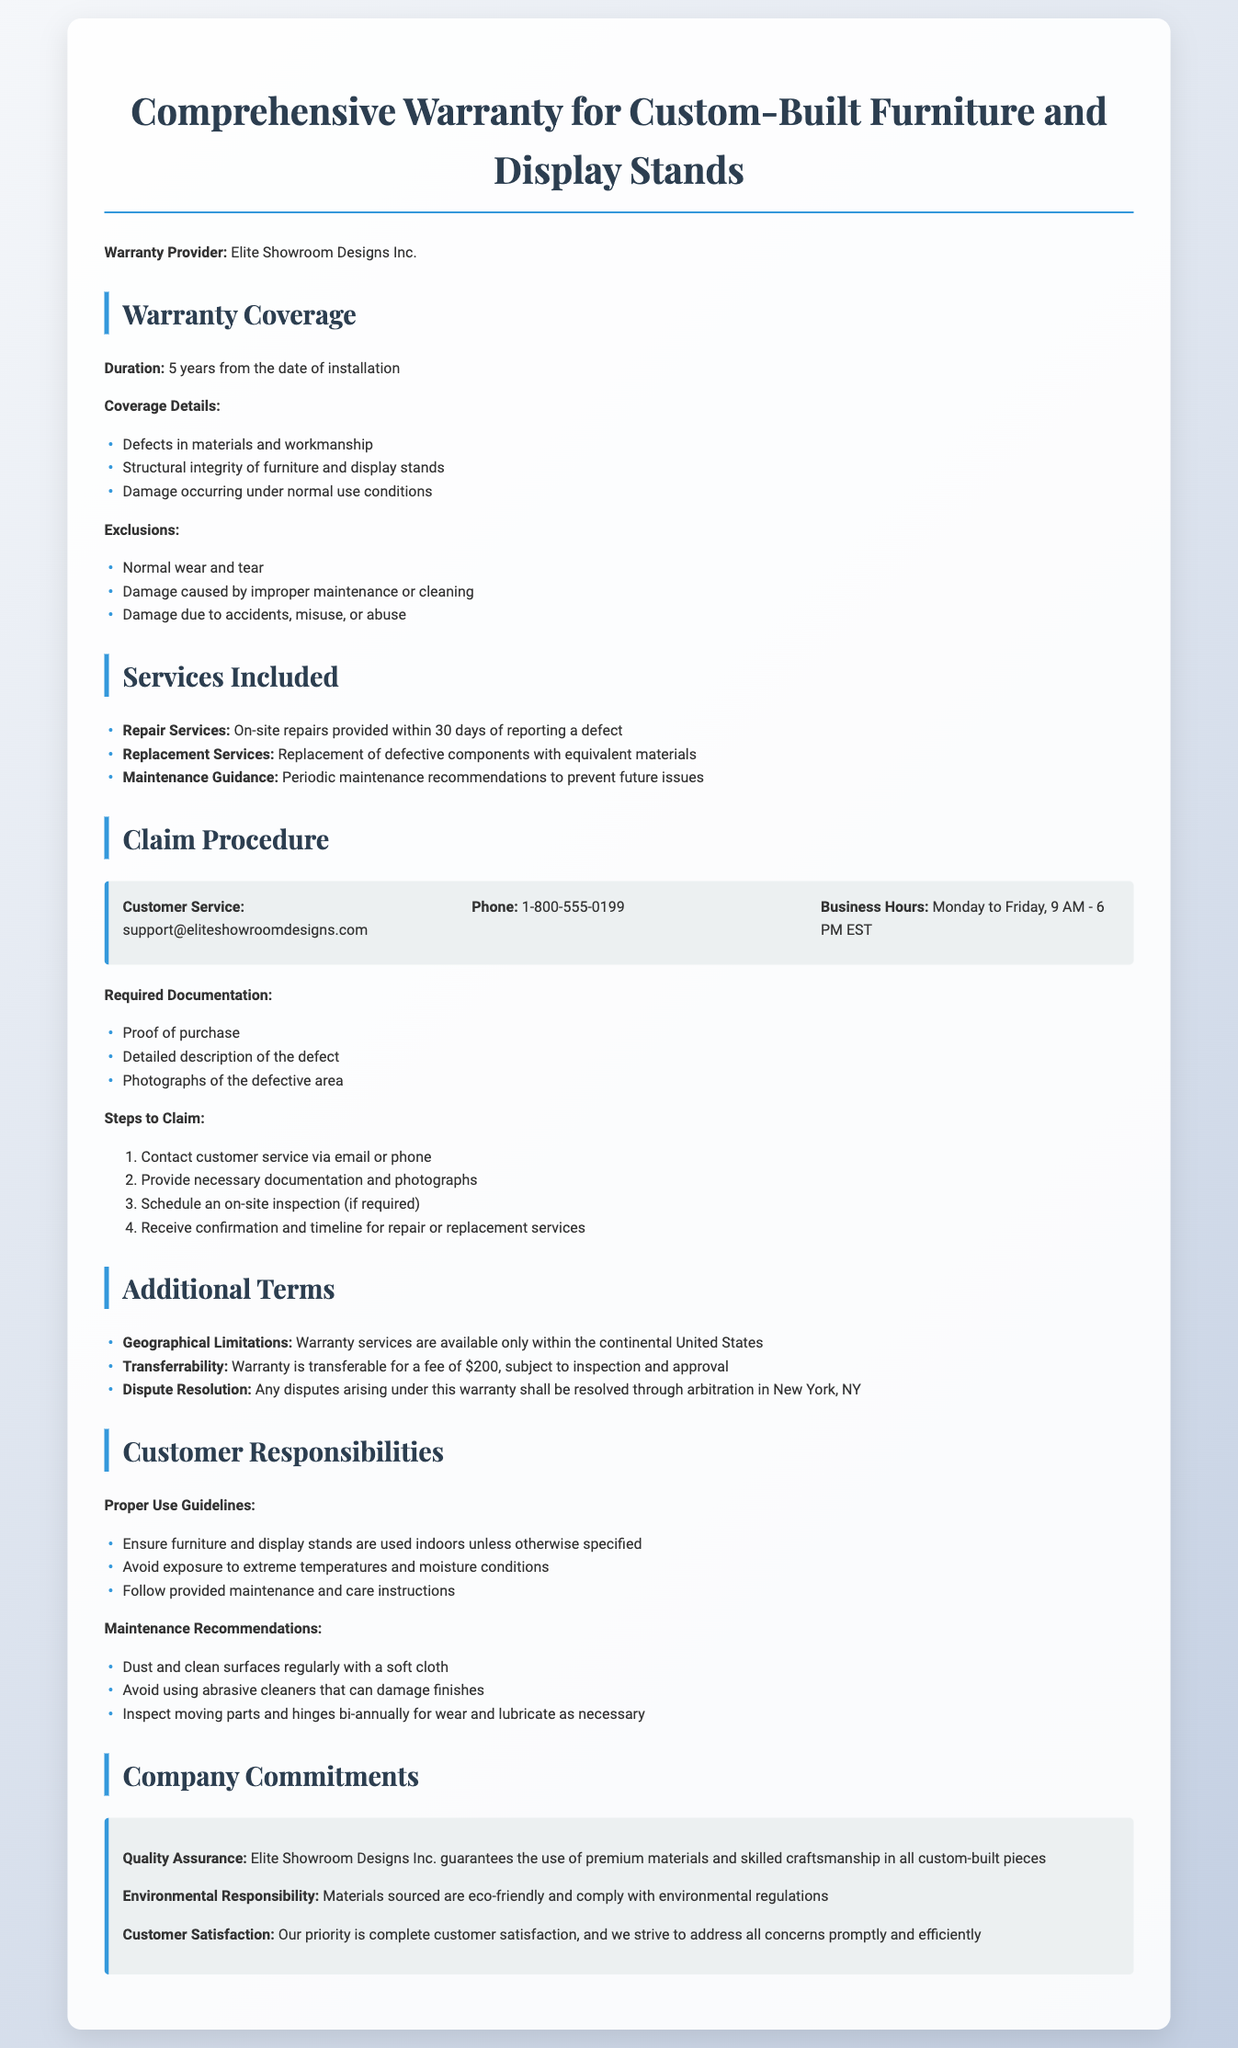What is the warranty duration? The warranty duration is explicitly stated in the document as 5 years from the date of installation.
Answer: 5 years What types of damage are excluded from warranty coverage? The document lists specific exclusions under warranty coverage, including normal wear and tear, damage caused by improper maintenance, and damage due to accidents.
Answer: Normal wear and tear, damage caused by improper maintenance or cleaning, damage due to accidents, misuse, or abuse What services are included in the warranty? The services included are detailed in the document under "Services Included," such as on-site repairs and replacement services.
Answer: Repair Services, Replacement Services, Maintenance Guidance What is the required documentation for a claim? The document outlines required documentation for claims that must be submitted to customer service.
Answer: Proof of purchase, detailed description of the defect, photographs of the defective area Where are warranty services available? The geographical limitations regarding warranty services are specified in the document, stating where the services can be claimed.
Answer: Continental United States How much is the fee for warranty transferability? The transferability fee is mentioned, along with the conditions under which the warranty can be transferred.
Answer: $200 What is the main commitment of Elite Showroom Designs Inc.? The document specifies commitments made by the company pertaining to quality, environmental responsibility, and customer satisfaction.
Answer: Quality Assurance, Environmental Responsibility, Customer Satisfaction What are the proper use guidelines for the furniture? The guidelines for the proper use of furniture are provided under "Customer Responsibilities."
Answer: Used indoors, avoid exposure to extreme temperatures and moisture How long do you have to wait for repair services after reporting a defect? The timeframe for repair services is indicated in the document, specifying how soon they should respond after a defect is reported.
Answer: 30 days 